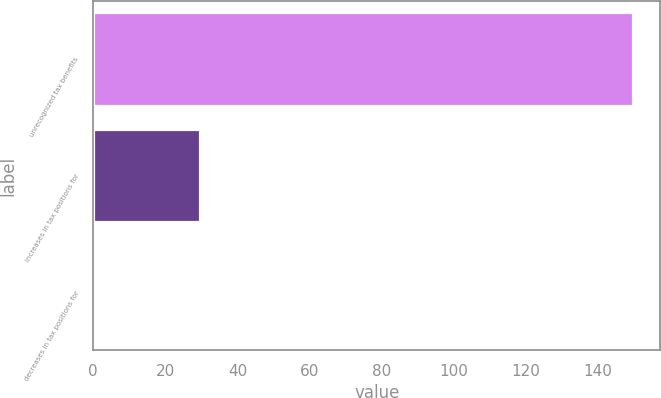Convert chart to OTSL. <chart><loc_0><loc_0><loc_500><loc_500><bar_chart><fcel>unrecognized tax benefits<fcel>increases in tax positions for<fcel>decreases in tax positions for<nl><fcel>149.78<fcel>29.66<fcel>0.1<nl></chart> 